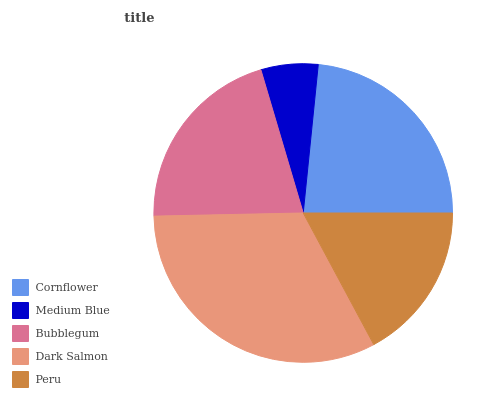Is Medium Blue the minimum?
Answer yes or no. Yes. Is Dark Salmon the maximum?
Answer yes or no. Yes. Is Bubblegum the minimum?
Answer yes or no. No. Is Bubblegum the maximum?
Answer yes or no. No. Is Bubblegum greater than Medium Blue?
Answer yes or no. Yes. Is Medium Blue less than Bubblegum?
Answer yes or no. Yes. Is Medium Blue greater than Bubblegum?
Answer yes or no. No. Is Bubblegum less than Medium Blue?
Answer yes or no. No. Is Bubblegum the high median?
Answer yes or no. Yes. Is Bubblegum the low median?
Answer yes or no. Yes. Is Peru the high median?
Answer yes or no. No. Is Cornflower the low median?
Answer yes or no. No. 